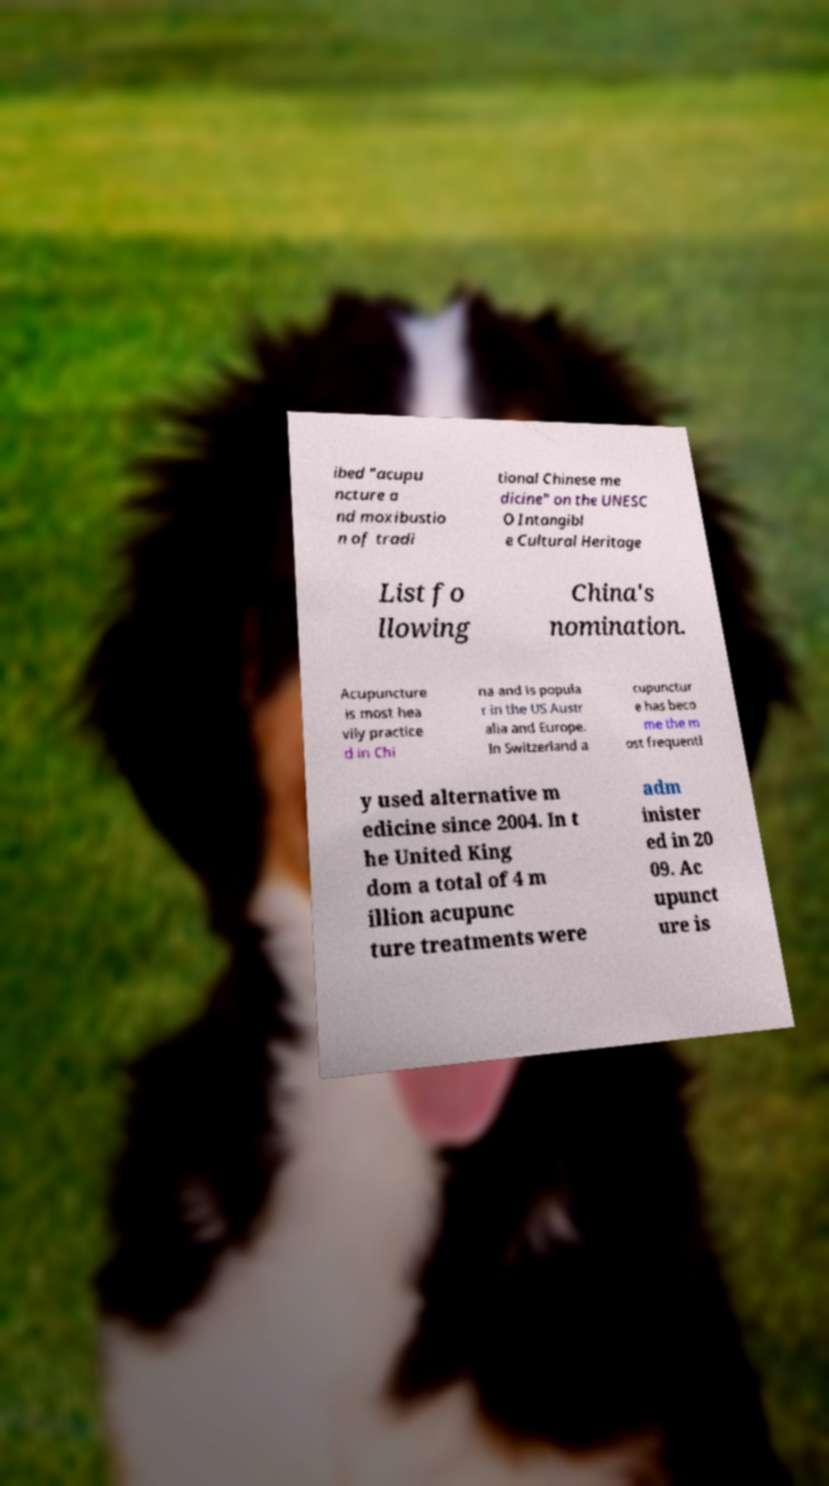Could you assist in decoding the text presented in this image and type it out clearly? ibed "acupu ncture a nd moxibustio n of tradi tional Chinese me dicine" on the UNESC O Intangibl e Cultural Heritage List fo llowing China's nomination. Acupuncture is most hea vily practice d in Chi na and is popula r in the US Austr alia and Europe. In Switzerland a cupunctur e has beco me the m ost frequentl y used alternative m edicine since 2004. In t he United King dom a total of 4 m illion acupunc ture treatments were adm inister ed in 20 09. Ac upunct ure is 